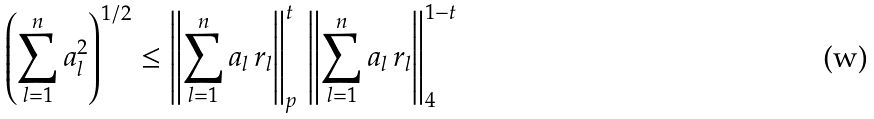Convert formula to latex. <formula><loc_0><loc_0><loc_500><loc_500>\left ( \sum _ { l = 1 } ^ { n } a _ { l } ^ { 2 } \right ) ^ { 1 / 2 } \leq \left \| \sum _ { l = 1 } ^ { n } a _ { l } \, r _ { l } \right \| _ { p } ^ { t } \, \left \| \sum _ { l = 1 } ^ { n } a _ { l } \, r _ { l } \right \| _ { 4 } ^ { 1 - t }</formula> 